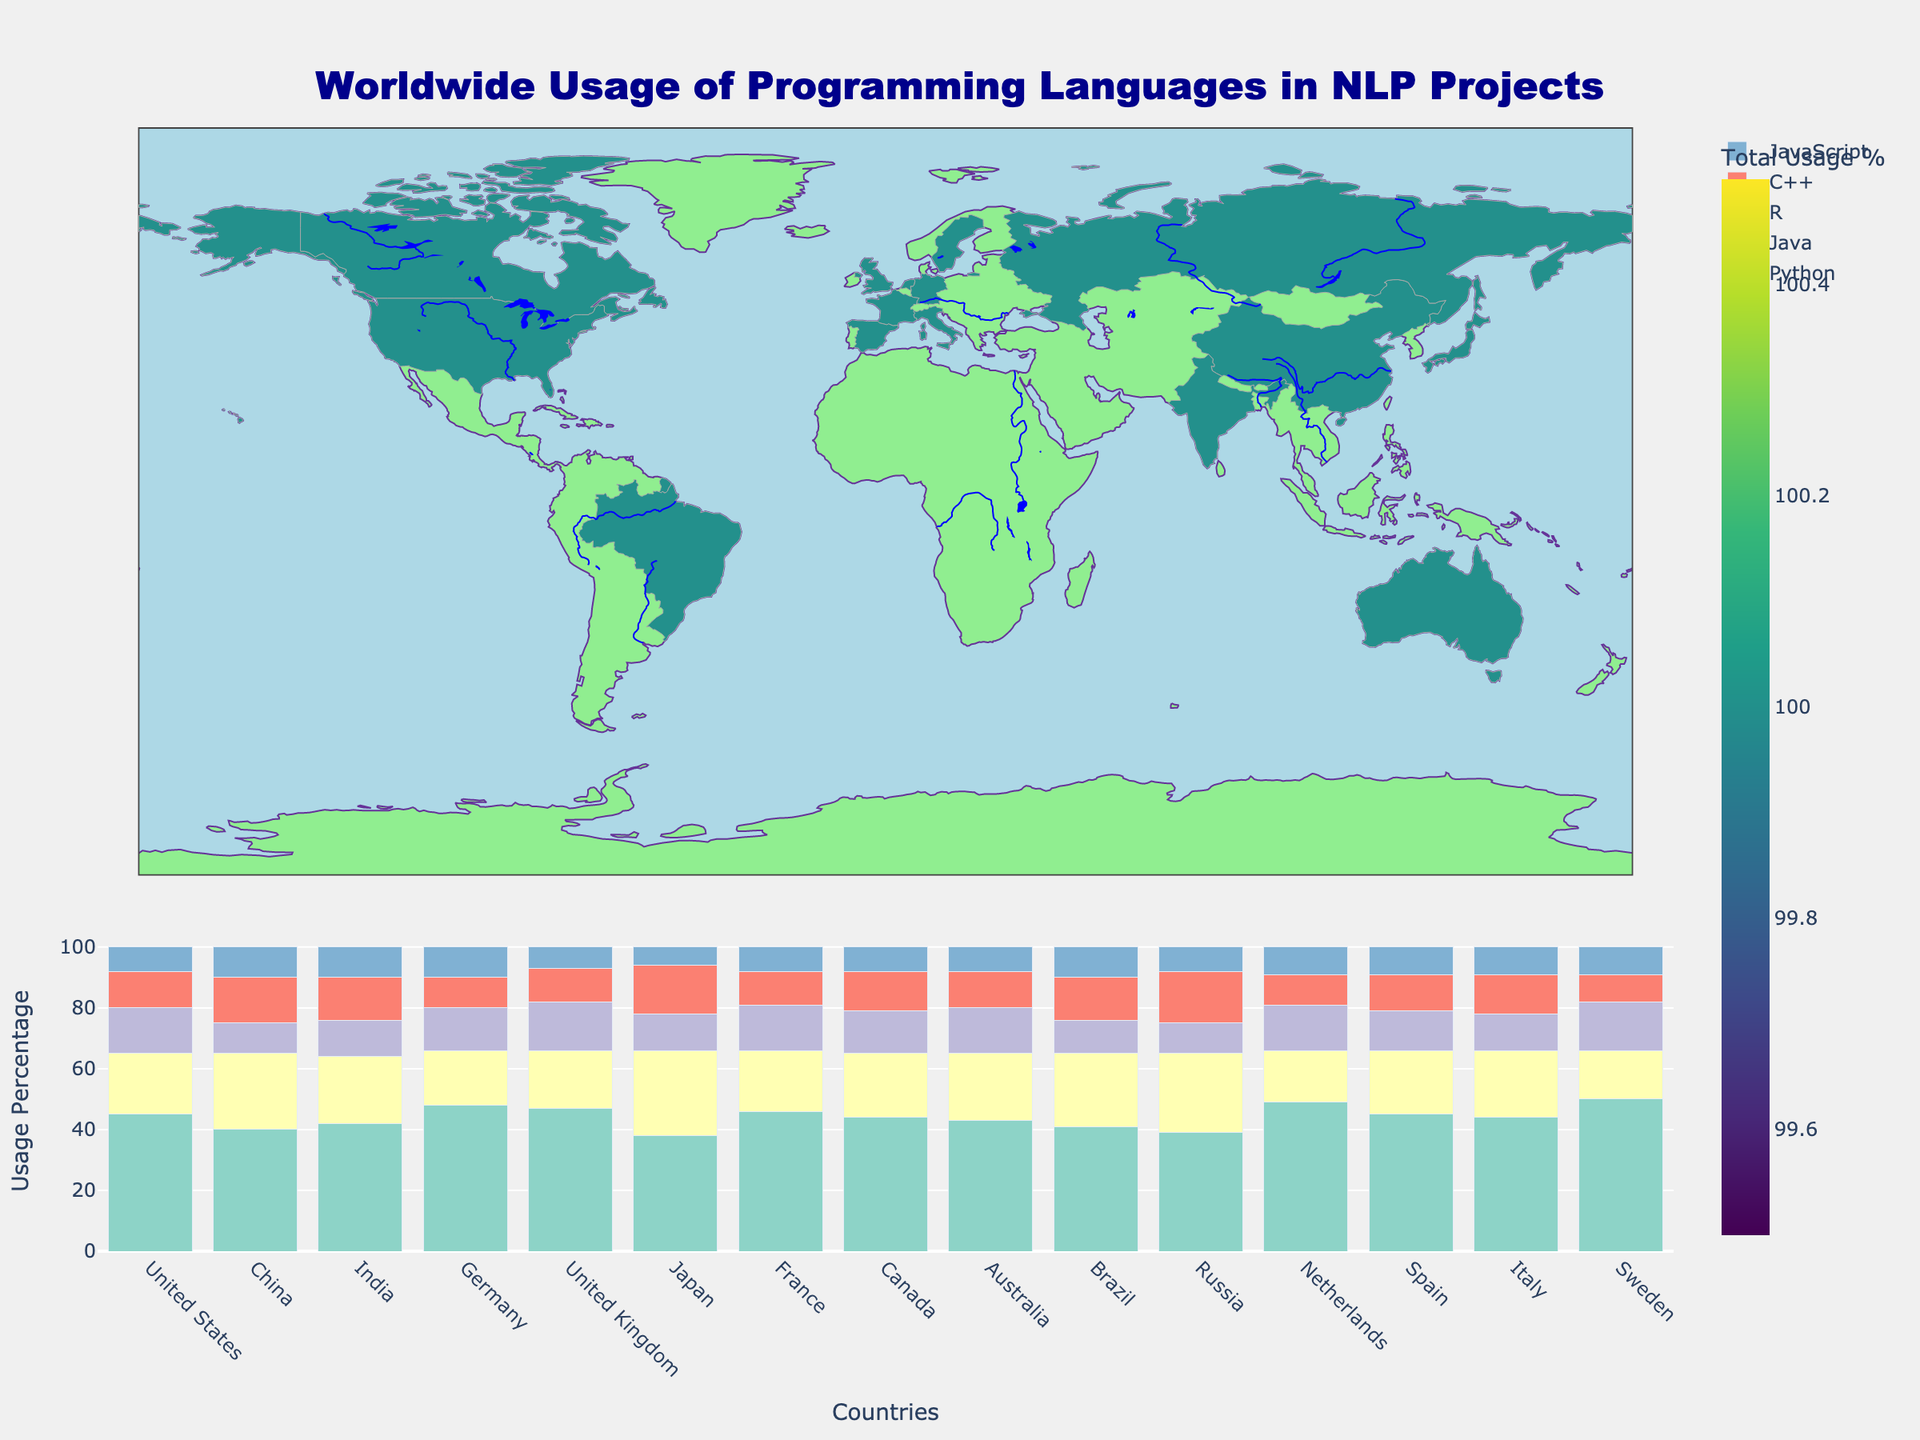What is the total usage percentage of programming languages in the United States? Look at the choropleth map and hover over the United States. The total usage percentage shown will be the sum of the percentages for all listed languages for the country.
Answer: 100 Which country has the highest usage percentage of Python in NLP projects? Refer to the stacked bar chart and identify the country with the tallest bar section for Python.
Answer: Sweden Compare the usage of Java in China and Russia. Which country uses it more and by how much? Find the bar sections for Java in China and Russia in the stacked bar chart. Subtract Russia's Java percentage from China's.
Answer: China uses Java 1% more Which language has the least usage percentage in Japan? Look at the bar sections for Japan in the stacked bar chart to identify the shortest bar section.
Answer: JavaScript What is the average usage percentage of R across all countries? Sum the percentages of R for all countries and divide by the number of countries (15). (15+10+12+14+16+12+15+14+15+11+10+15+13+12+16)/15 =
Answer: 13.5 Which two countries have the closest usage percentages of Python, and what are their values? Identify the bar sections for Python in each country, then find the two closest values and check the corresponding country names.
Answer: Netherlands (49) and Germany (48) How does the usage of C++ in Japan compare to its usage in Brazil? Check the bar sections for C++ in Japan and Brazil and note their respective values.
Answer: Japan uses C++ 2% more than Brazil In which country is JavaScript used more than both R and C++? For each country, compare the bar section sizes of JavaScript with R and C++. Identify any country where JavaScript's bar section exceeds both others.
Answer: China What is the total percentage usage of all languages combined in India? Sum the usage percentages of Python, Java, R, C++, and JavaScript in India. 42+22+12+14+10
Answer: 100 Which country has the most varied usage percentages across different programming languages? Identify the country with the greatest difference between its highest and lowest values in the stacked bar chart.
Answer: Japan (difference of 28-6 = 22) 